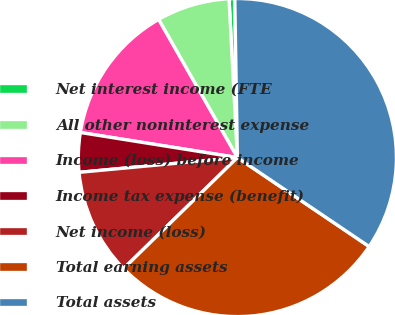Convert chart to OTSL. <chart><loc_0><loc_0><loc_500><loc_500><pie_chart><fcel>Net interest income (FTE<fcel>All other noninterest expense<fcel>Income (loss) before income<fcel>Income tax expense (benefit)<fcel>Net income (loss)<fcel>Total earning assets<fcel>Total assets<nl><fcel>0.58%<fcel>7.41%<fcel>14.23%<fcel>4.0%<fcel>10.82%<fcel>28.24%<fcel>34.71%<nl></chart> 